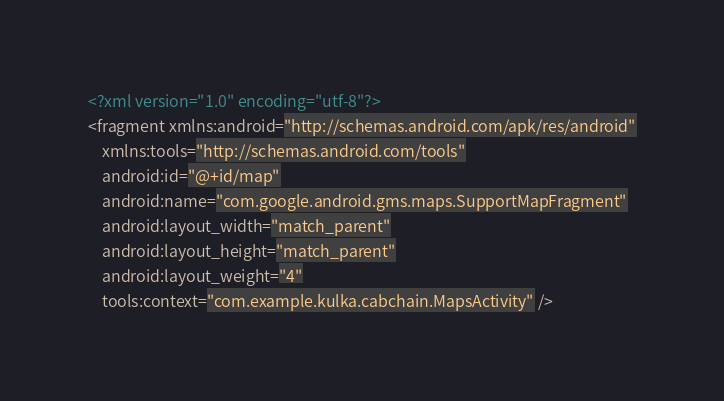Convert code to text. <code><loc_0><loc_0><loc_500><loc_500><_XML_><?xml version="1.0" encoding="utf-8"?>
<fragment xmlns:android="http://schemas.android.com/apk/res/android"
    xmlns:tools="http://schemas.android.com/tools"
    android:id="@+id/map"
    android:name="com.google.android.gms.maps.SupportMapFragment"
    android:layout_width="match_parent"
    android:layout_height="match_parent"
    android:layout_weight="4"
    tools:context="com.example.kulka.cabchain.MapsActivity" />


</code> 